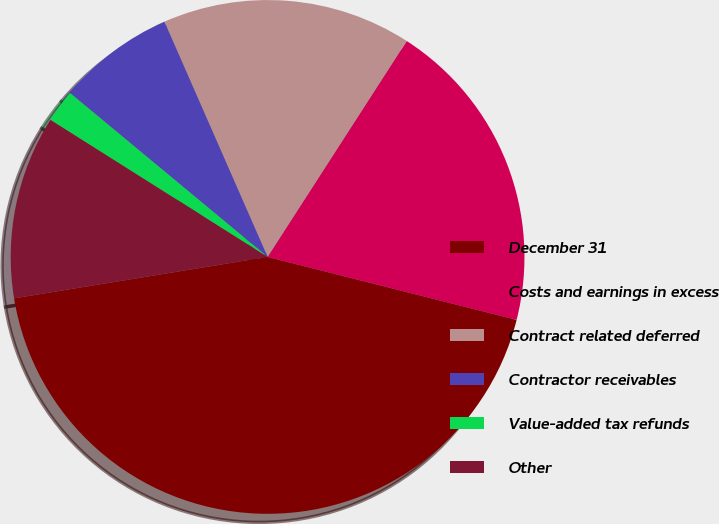Convert chart to OTSL. <chart><loc_0><loc_0><loc_500><loc_500><pie_chart><fcel>December 31<fcel>Costs and earnings in excess<fcel>Contract related deferred<fcel>Contractor receivables<fcel>Value-added tax refunds<fcel>Other<nl><fcel>43.48%<fcel>19.83%<fcel>15.69%<fcel>7.4%<fcel>2.06%<fcel>11.54%<nl></chart> 